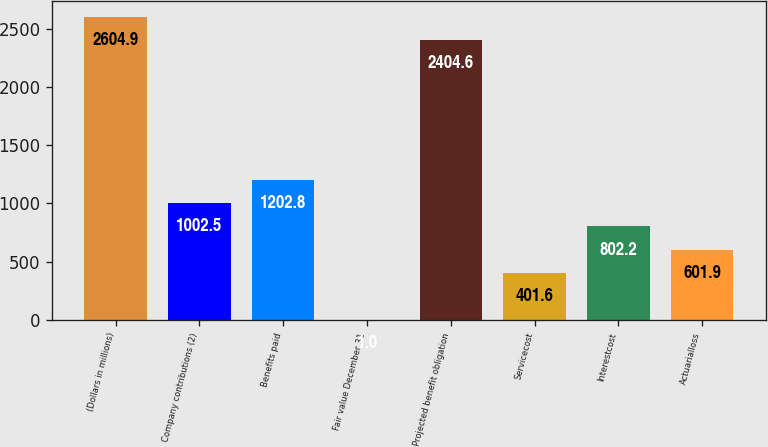Convert chart to OTSL. <chart><loc_0><loc_0><loc_500><loc_500><bar_chart><fcel>(Dollars in millions)<fcel>Company contributions (2)<fcel>Benefits paid<fcel>Fair value December 31<fcel>Projected benefit obligation<fcel>Servicecost<fcel>Interestcost<fcel>Actuarialloss<nl><fcel>2604.9<fcel>1002.5<fcel>1202.8<fcel>1<fcel>2404.6<fcel>401.6<fcel>802.2<fcel>601.9<nl></chart> 